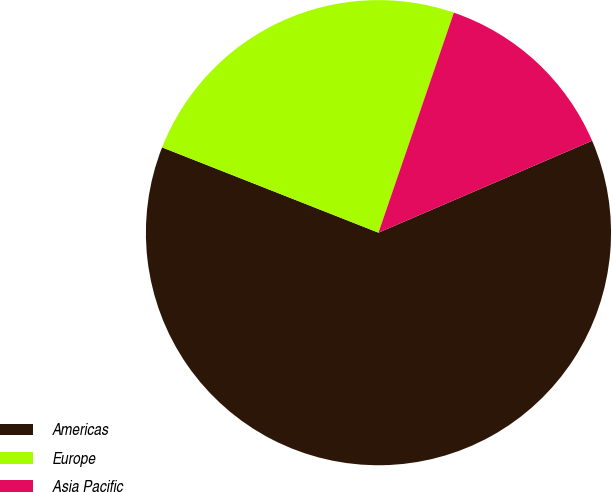<chart> <loc_0><loc_0><loc_500><loc_500><pie_chart><fcel>Americas<fcel>Europe<fcel>Asia Pacific<nl><fcel>62.45%<fcel>24.28%<fcel>13.28%<nl></chart> 